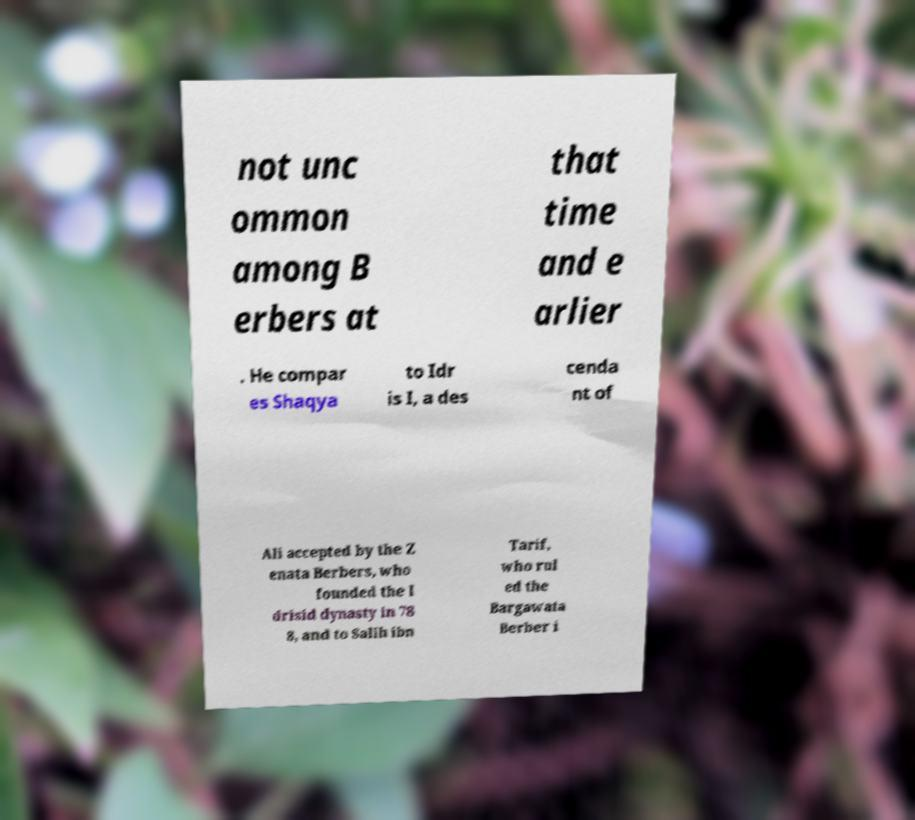Please read and relay the text visible in this image. What does it say? not unc ommon among B erbers at that time and e arlier . He compar es Shaqya to Idr is I, a des cenda nt of Ali accepted by the Z enata Berbers, who founded the I drisid dynasty in 78 8, and to Salih ibn Tarif, who rul ed the Bargawata Berber i 